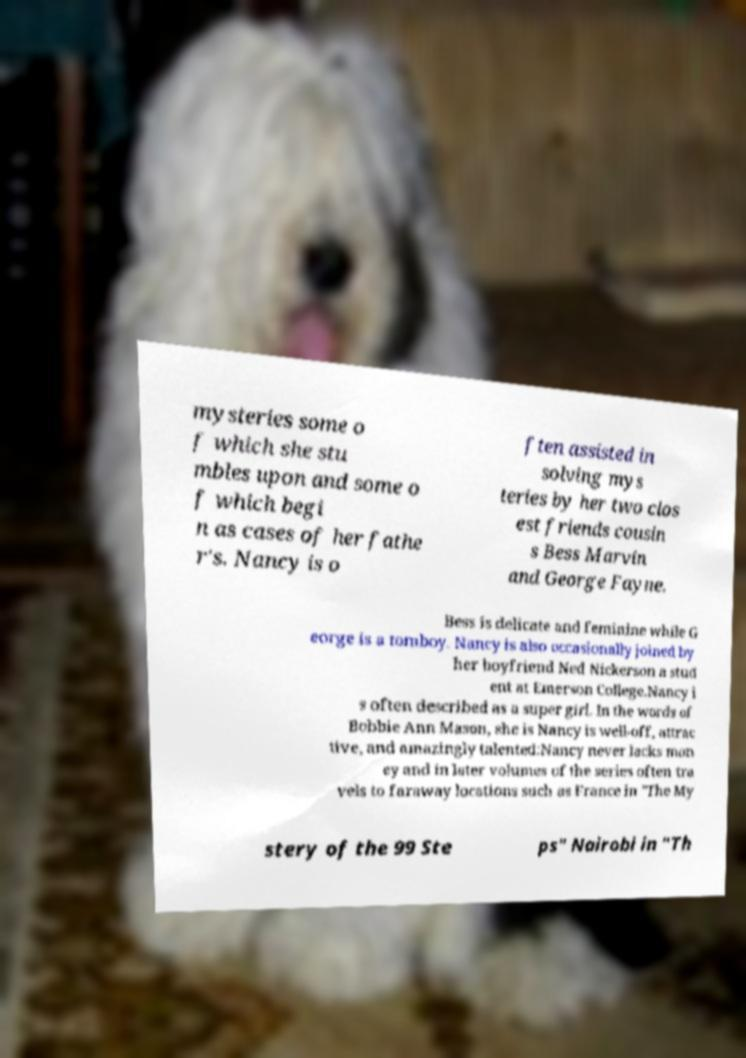For documentation purposes, I need the text within this image transcribed. Could you provide that? mysteries some o f which she stu mbles upon and some o f which begi n as cases of her fathe r's. Nancy is o ften assisted in solving mys teries by her two clos est friends cousin s Bess Marvin and George Fayne. Bess is delicate and feminine while G eorge is a tomboy. Nancy is also occasionally joined by her boyfriend Ned Nickerson a stud ent at Emerson College.Nancy i s often described as a super girl. In the words of Bobbie Ann Mason, she is Nancy is well-off, attrac tive, and amazingly talented:Nancy never lacks mon ey and in later volumes of the series often tra vels to faraway locations such as France in "The My stery of the 99 Ste ps" Nairobi in "Th 